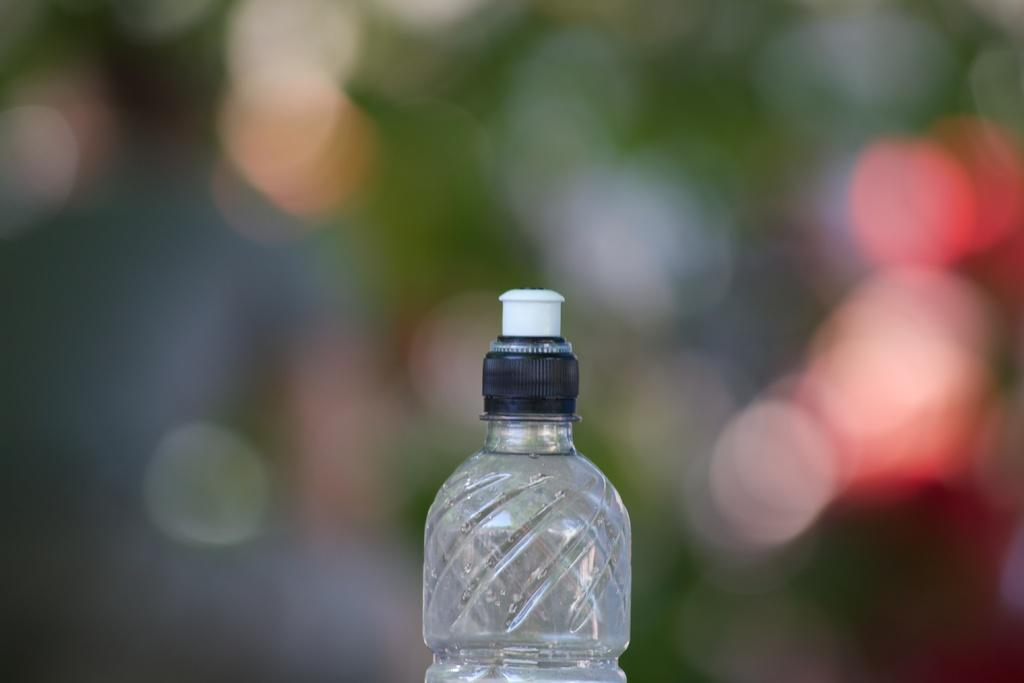What object can be seen in the image? There is a bottle in the image. What type of plantation is visible in the image? There is no plantation present in the image; it only features a bottle. How many goats can be seen interacting with the bottle in the image? There are no goats present in the image, and therefore no interaction with the bottle can be observed. 